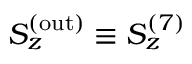<formula> <loc_0><loc_0><loc_500><loc_500>S _ { z } ^ { ( o u t ) } \equiv S _ { z } ^ { ( 7 ) }</formula> 